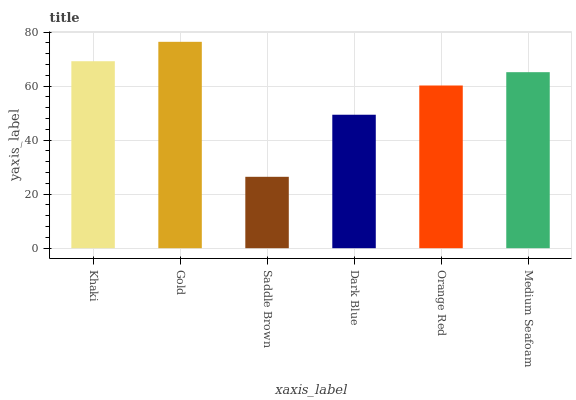Is Saddle Brown the minimum?
Answer yes or no. Yes. Is Gold the maximum?
Answer yes or no. Yes. Is Gold the minimum?
Answer yes or no. No. Is Saddle Brown the maximum?
Answer yes or no. No. Is Gold greater than Saddle Brown?
Answer yes or no. Yes. Is Saddle Brown less than Gold?
Answer yes or no. Yes. Is Saddle Brown greater than Gold?
Answer yes or no. No. Is Gold less than Saddle Brown?
Answer yes or no. No. Is Medium Seafoam the high median?
Answer yes or no. Yes. Is Orange Red the low median?
Answer yes or no. Yes. Is Khaki the high median?
Answer yes or no. No. Is Saddle Brown the low median?
Answer yes or no. No. 